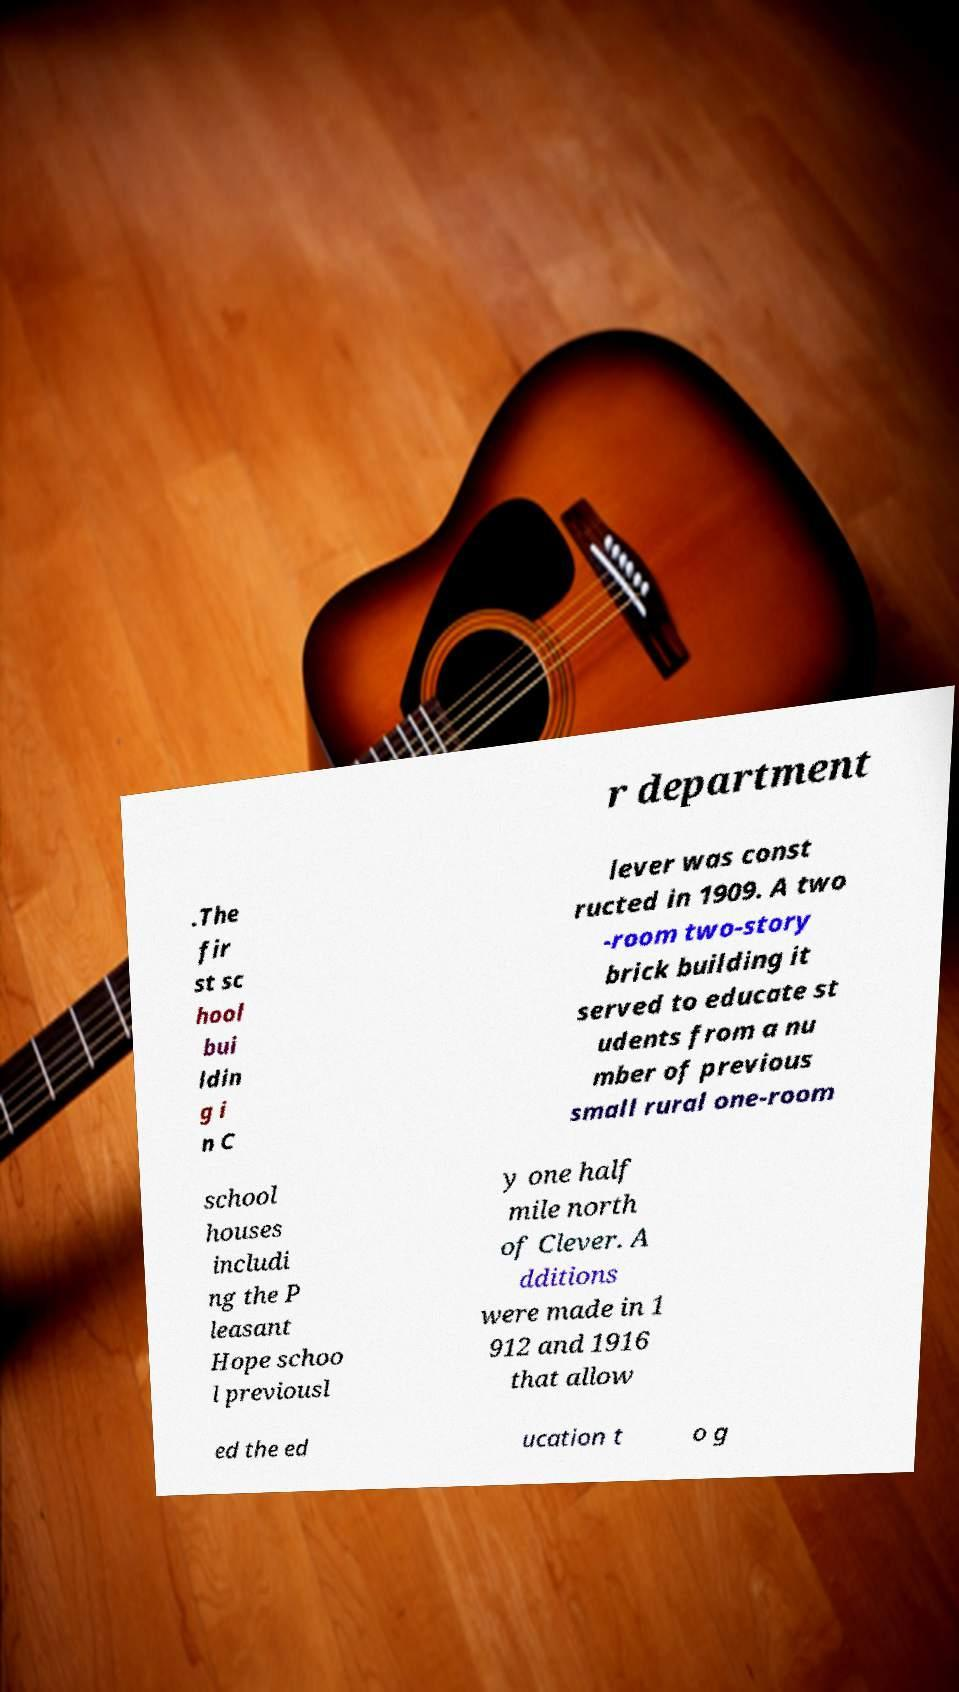Please read and relay the text visible in this image. What does it say? r department .The fir st sc hool bui ldin g i n C lever was const ructed in 1909. A two -room two-story brick building it served to educate st udents from a nu mber of previous small rural one-room school houses includi ng the P leasant Hope schoo l previousl y one half mile north of Clever. A dditions were made in 1 912 and 1916 that allow ed the ed ucation t o g 